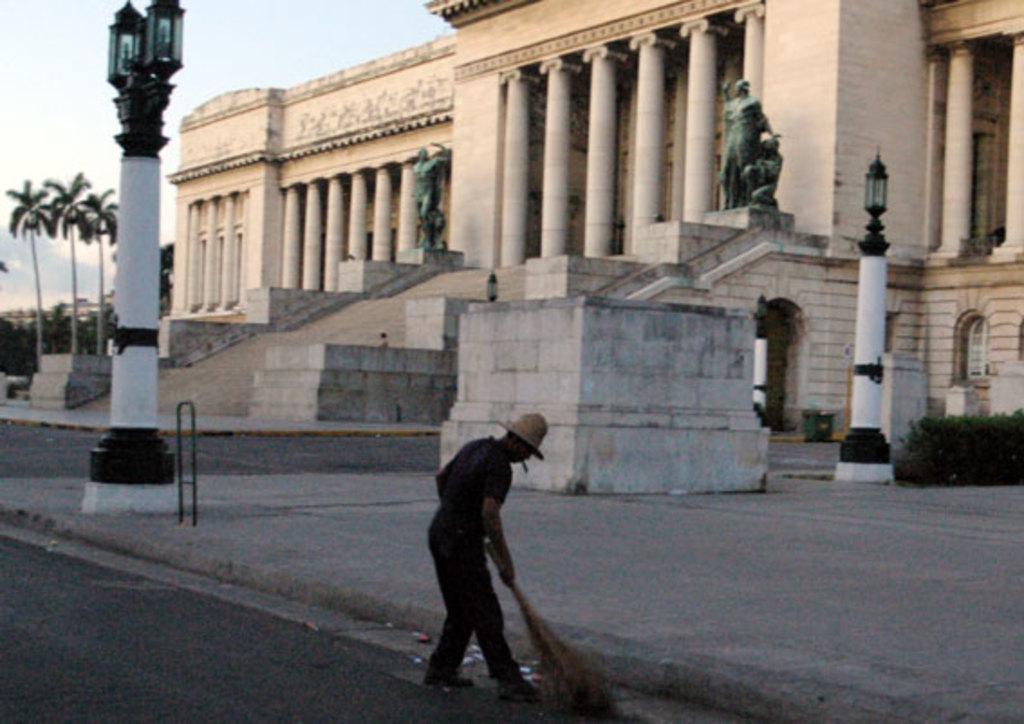In one or two sentences, can you explain what this image depicts? In this image there is a person sweeping the road surface, behind the person there is a building with two statues in front of the building, in front of the building there are stairs, beside the building there are trees, in front of the building there is a lamp post. 